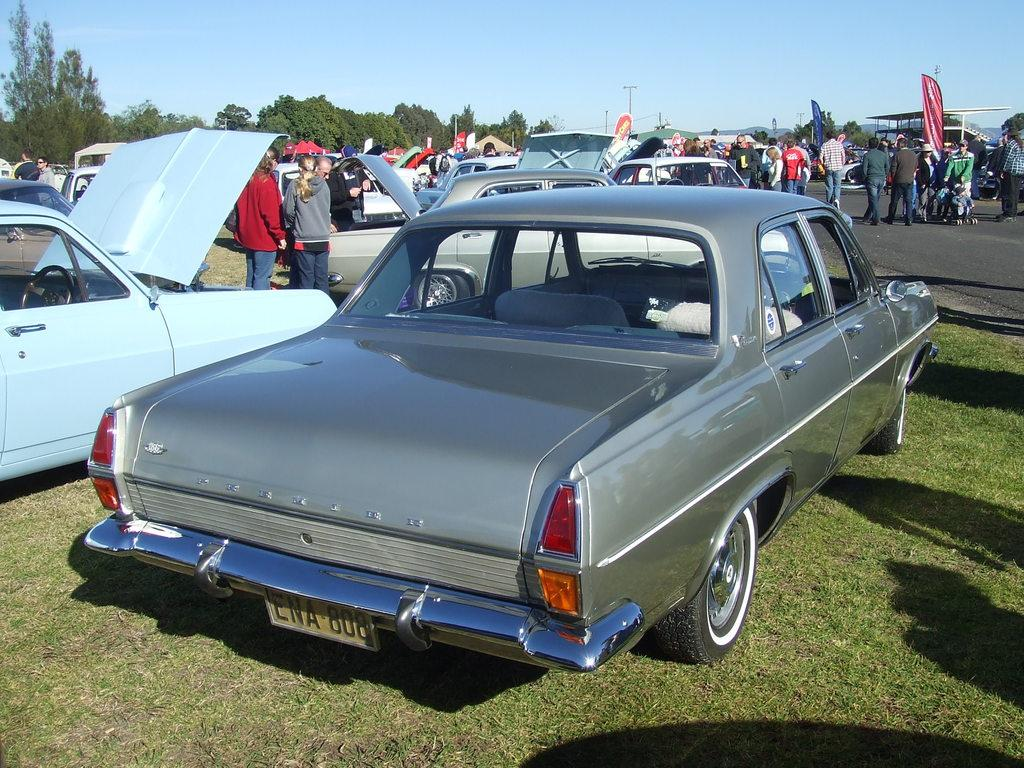What is located in the center of the image? There are cars in the center of the image. Can you describe the people visible in the image? There are people visible in the image. What type of surface can be seen in the image? There is a road in the image. What type of vegetation is present at the bottom of the image? Grass is present at the bottom of the image. What can be seen in the background of the image? There are trees, poles, a shed, and the sky visible in the background of the image. What color is the eye-catching ornament hanging from the shed in the image? There is no eye-catching ornament hanging from the shed in the image. How many people are sleeping in the image? There are no people sleeping in the image; the people visible are standing or walking. 